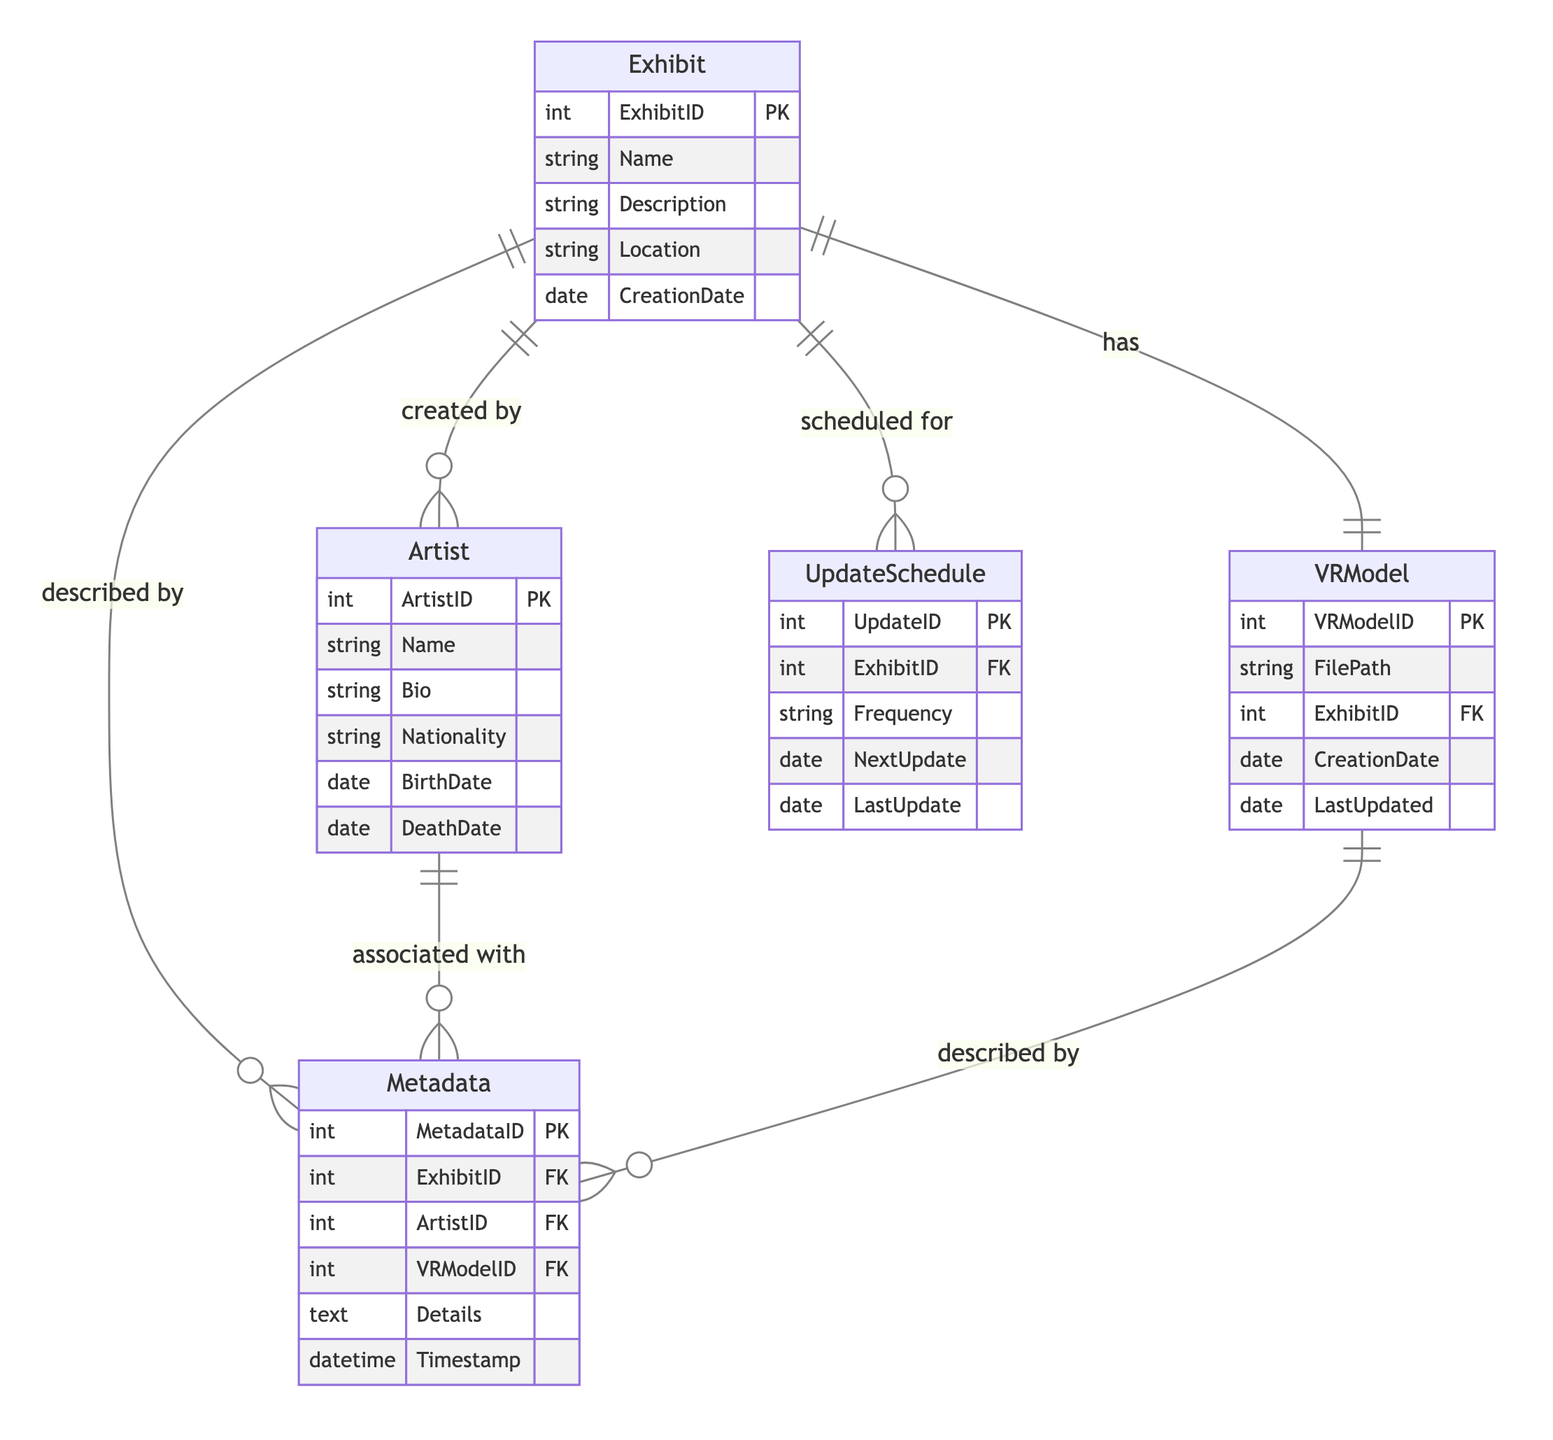What is the primary key of the Exhibit entity? The primary key of the Exhibit entity is ExhibitID, which uniquely identifies each exhibit in the collection management system.
Answer: ExhibitID How many attributes does the Artist entity have? The Artist entity has six attributes: ArtistID, Name, Bio, Nationality, BirthDate, and DeathDate.
Answer: Six Which entity has a one-to-one relationship with Exhibit? The VRModel entity has a one-to-one relationship with Exhibit, indicating that each exhibit is associated with one unique VR model.
Answer: VRModel What relationship connects Metadata to Artist? The relationship that connects Metadata to Artist is a many-to-one relationship, meaning that multiple pieces of metadata can be associated with a single artist.
Answer: Many-to-One What attribute in the UpdateSchedule entity indicates the next scheduled update? The NextUpdate attribute in the UpdateSchedule entity indicates when the next update for an exhibit is scheduled to occur.
Answer: NextUpdate Which entity describes the connection between Metadata and the VRModel? The connection between Metadata and the VRModel is captured in the Metadata-VRModel relationship, which is a many-to-one relationship.
Answer: Metadata-VRModel What is the foreign key in the VRModel entity? The foreign key in the VRModel entity is ExhibitID, which links the VR model to the corresponding exhibit it represents.
Answer: ExhibitID What type of relationship exists between Exhibit and UpdateSchedule? The relationship between Exhibit and UpdateSchedule is a many-to-one relationship, meaning that many update schedules can be associated with a single exhibit.
Answer: Many-to-One What does the attribute Details in the Metadata entity store? The Details attribute in the Metadata entity stores descriptive information related to a specific exhibit, artist, and VR model.
Answer: Descriptive information 